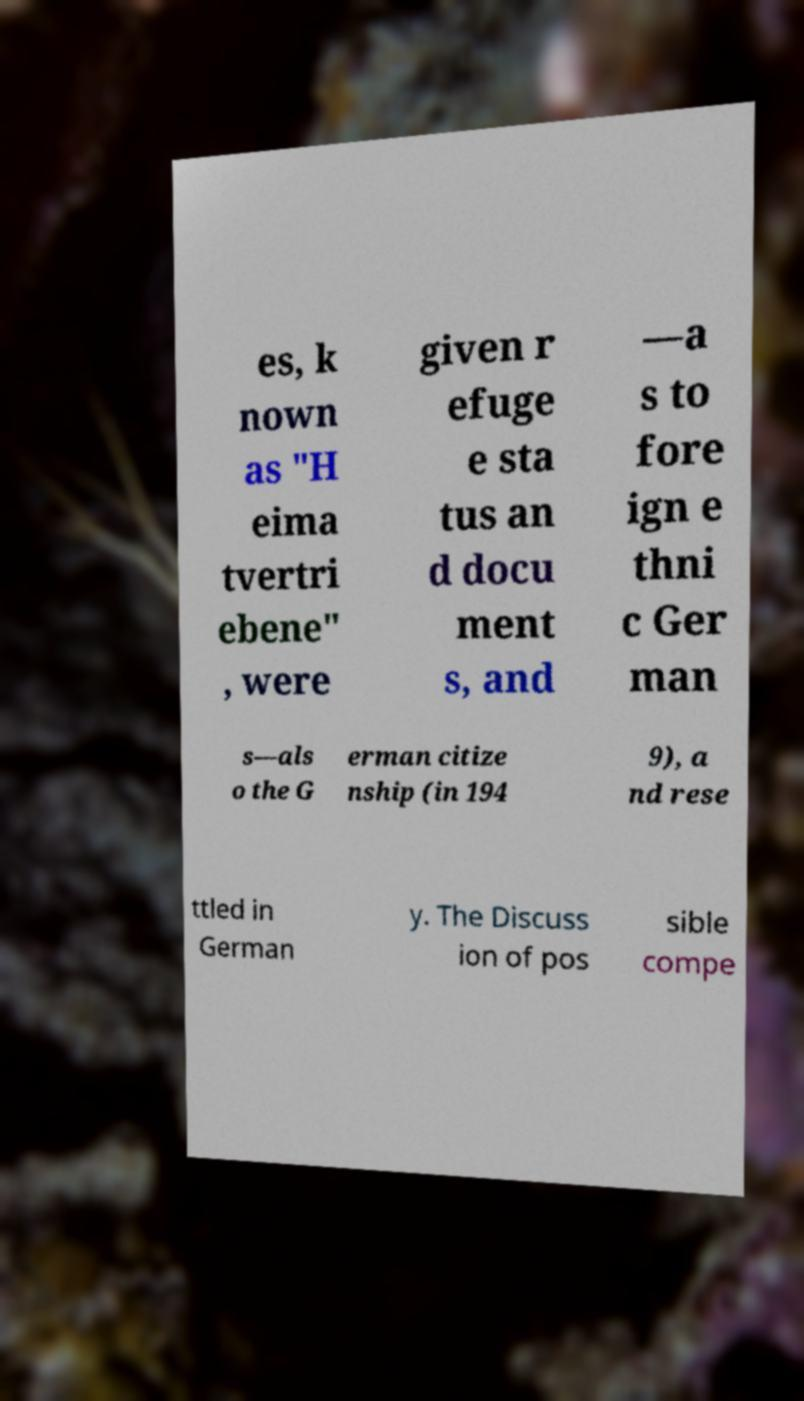Can you accurately transcribe the text from the provided image for me? es, k nown as "H eima tvertri ebene" , were given r efuge e sta tus an d docu ment s, and —a s to fore ign e thni c Ger man s—als o the G erman citize nship (in 194 9), a nd rese ttled in German y. The Discuss ion of pos sible compe 